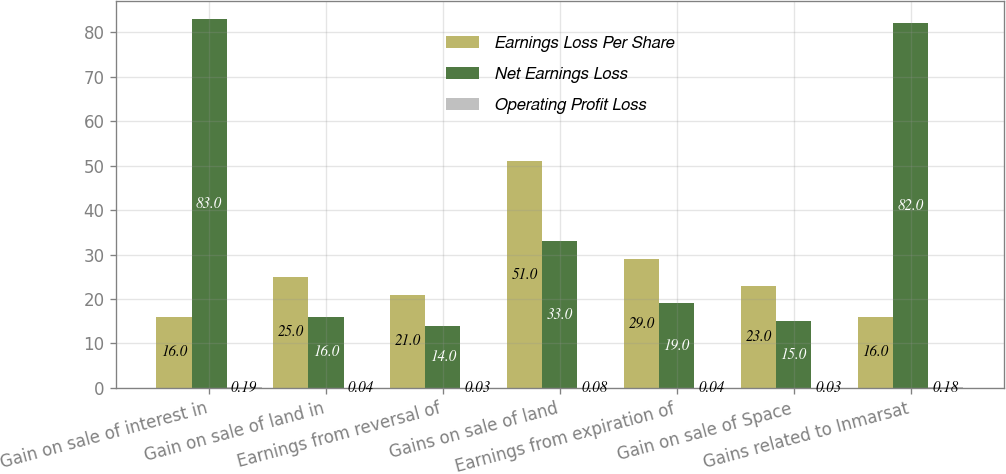Convert chart to OTSL. <chart><loc_0><loc_0><loc_500><loc_500><stacked_bar_chart><ecel><fcel>Gain on sale of interest in<fcel>Gain on sale of land in<fcel>Earnings from reversal of<fcel>Gains on sale of land<fcel>Earnings from expiration of<fcel>Gain on sale of Space<fcel>Gains related to Inmarsat<nl><fcel>Earnings Loss Per Share<fcel>16<fcel>25<fcel>21<fcel>51<fcel>29<fcel>23<fcel>16<nl><fcel>Net Earnings Loss<fcel>83<fcel>16<fcel>14<fcel>33<fcel>19<fcel>15<fcel>82<nl><fcel>Operating Profit Loss<fcel>0.19<fcel>0.04<fcel>0.03<fcel>0.08<fcel>0.04<fcel>0.03<fcel>0.18<nl></chart> 